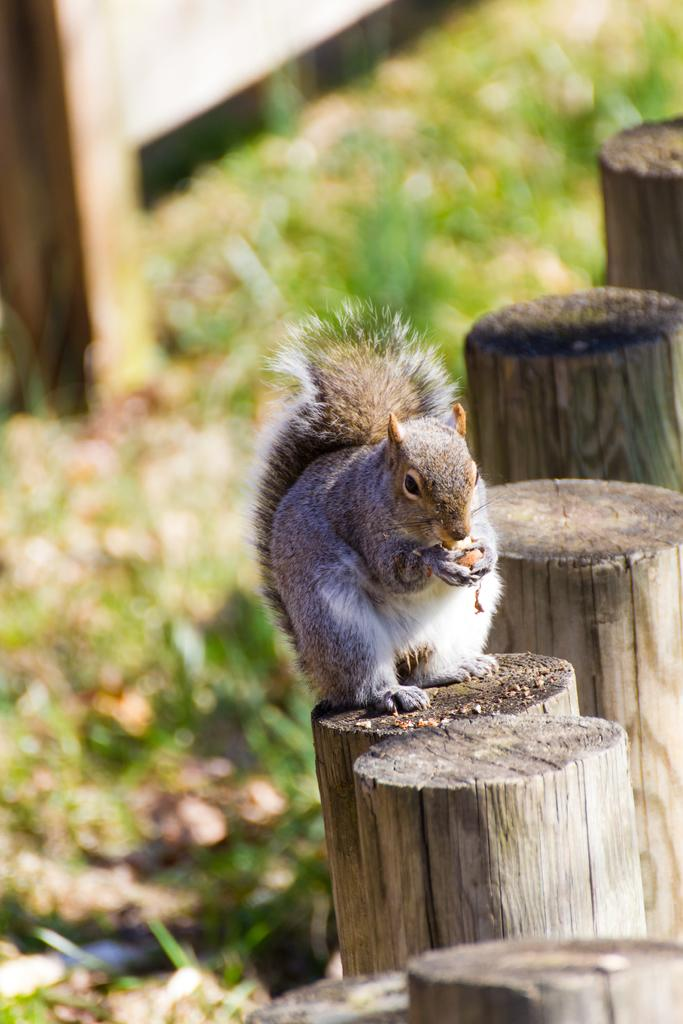What animal can be seen in the image? There is a squirrel in the image. What is the squirrel sitting on? The squirrel is sitting on a wooden stick. What type of vegetation is visible at the bottom of the image? There is green grass at the bottom of the image. What can be seen in the background of the image? There is a fencing in the background of the image. What type of pocket can be seen on the squirrel in the image? There are no pockets visible on the squirrel in the image, as squirrels do not have pockets. 